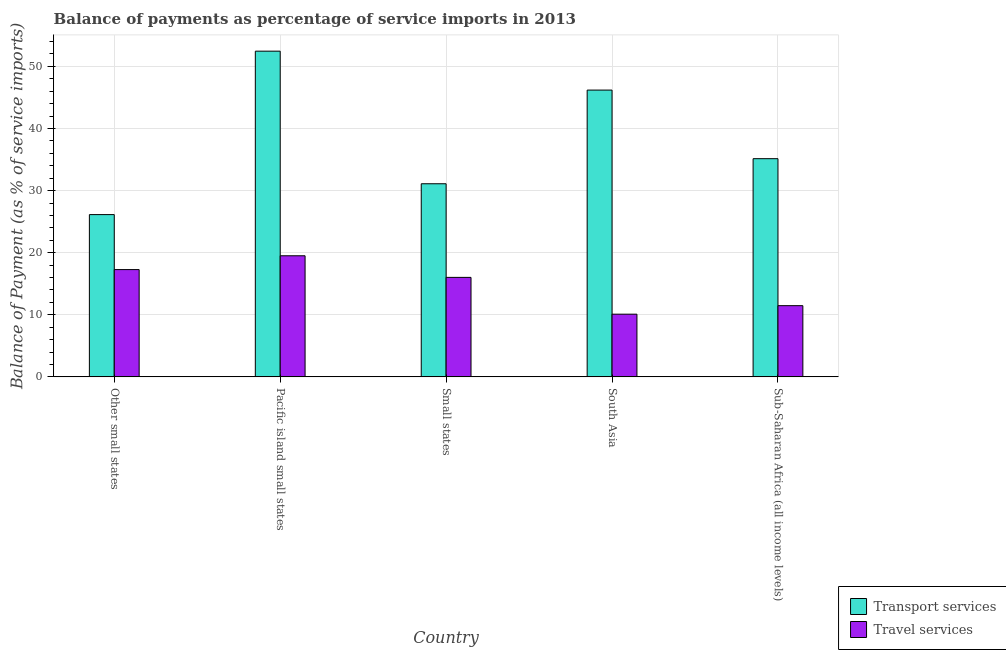How many different coloured bars are there?
Give a very brief answer. 2. How many groups of bars are there?
Offer a terse response. 5. Are the number of bars on each tick of the X-axis equal?
Provide a short and direct response. Yes. How many bars are there on the 1st tick from the left?
Provide a succinct answer. 2. What is the label of the 2nd group of bars from the left?
Keep it short and to the point. Pacific island small states. What is the balance of payments of transport services in Pacific island small states?
Provide a succinct answer. 52.45. Across all countries, what is the maximum balance of payments of travel services?
Offer a terse response. 19.5. Across all countries, what is the minimum balance of payments of travel services?
Provide a succinct answer. 10.1. In which country was the balance of payments of travel services maximum?
Offer a very short reply. Pacific island small states. In which country was the balance of payments of travel services minimum?
Offer a very short reply. South Asia. What is the total balance of payments of transport services in the graph?
Keep it short and to the point. 191.01. What is the difference between the balance of payments of travel services in Other small states and that in Small states?
Provide a short and direct response. 1.26. What is the difference between the balance of payments of travel services in Sub-Saharan Africa (all income levels) and the balance of payments of transport services in South Asia?
Provide a succinct answer. -34.72. What is the average balance of payments of transport services per country?
Provide a short and direct response. 38.2. What is the difference between the balance of payments of travel services and balance of payments of transport services in Pacific island small states?
Your response must be concise. -32.95. What is the ratio of the balance of payments of transport services in South Asia to that in Sub-Saharan Africa (all income levels)?
Keep it short and to the point. 1.31. What is the difference between the highest and the second highest balance of payments of transport services?
Offer a terse response. 6.27. What is the difference between the highest and the lowest balance of payments of transport services?
Your answer should be compact. 26.32. What does the 1st bar from the left in South Asia represents?
Your answer should be very brief. Transport services. What does the 1st bar from the right in Small states represents?
Give a very brief answer. Travel services. How many bars are there?
Your answer should be very brief. 10. How many countries are there in the graph?
Your answer should be very brief. 5. Are the values on the major ticks of Y-axis written in scientific E-notation?
Provide a succinct answer. No. Does the graph contain grids?
Your answer should be compact. Yes. Where does the legend appear in the graph?
Keep it short and to the point. Bottom right. How many legend labels are there?
Make the answer very short. 2. How are the legend labels stacked?
Keep it short and to the point. Vertical. What is the title of the graph?
Provide a succinct answer. Balance of payments as percentage of service imports in 2013. What is the label or title of the Y-axis?
Offer a very short reply. Balance of Payment (as % of service imports). What is the Balance of Payment (as % of service imports) in Transport services in Other small states?
Provide a succinct answer. 26.13. What is the Balance of Payment (as % of service imports) of Travel services in Other small states?
Make the answer very short. 17.28. What is the Balance of Payment (as % of service imports) of Transport services in Pacific island small states?
Your answer should be very brief. 52.45. What is the Balance of Payment (as % of service imports) of Travel services in Pacific island small states?
Your response must be concise. 19.5. What is the Balance of Payment (as % of service imports) of Transport services in Small states?
Provide a short and direct response. 31.1. What is the Balance of Payment (as % of service imports) in Travel services in Small states?
Your response must be concise. 16.02. What is the Balance of Payment (as % of service imports) in Transport services in South Asia?
Ensure brevity in your answer.  46.18. What is the Balance of Payment (as % of service imports) of Travel services in South Asia?
Offer a terse response. 10.1. What is the Balance of Payment (as % of service imports) of Transport services in Sub-Saharan Africa (all income levels)?
Provide a short and direct response. 35.14. What is the Balance of Payment (as % of service imports) in Travel services in Sub-Saharan Africa (all income levels)?
Make the answer very short. 11.47. Across all countries, what is the maximum Balance of Payment (as % of service imports) of Transport services?
Your response must be concise. 52.45. Across all countries, what is the maximum Balance of Payment (as % of service imports) in Travel services?
Keep it short and to the point. 19.5. Across all countries, what is the minimum Balance of Payment (as % of service imports) in Transport services?
Offer a terse response. 26.13. Across all countries, what is the minimum Balance of Payment (as % of service imports) in Travel services?
Offer a very short reply. 10.1. What is the total Balance of Payment (as % of service imports) in Transport services in the graph?
Your answer should be compact. 191.01. What is the total Balance of Payment (as % of service imports) in Travel services in the graph?
Make the answer very short. 74.36. What is the difference between the Balance of Payment (as % of service imports) in Transport services in Other small states and that in Pacific island small states?
Give a very brief answer. -26.32. What is the difference between the Balance of Payment (as % of service imports) of Travel services in Other small states and that in Pacific island small states?
Your answer should be very brief. -2.23. What is the difference between the Balance of Payment (as % of service imports) of Transport services in Other small states and that in Small states?
Your answer should be very brief. -4.97. What is the difference between the Balance of Payment (as % of service imports) of Travel services in Other small states and that in Small states?
Keep it short and to the point. 1.25. What is the difference between the Balance of Payment (as % of service imports) of Transport services in Other small states and that in South Asia?
Keep it short and to the point. -20.05. What is the difference between the Balance of Payment (as % of service imports) in Travel services in Other small states and that in South Asia?
Keep it short and to the point. 7.18. What is the difference between the Balance of Payment (as % of service imports) of Transport services in Other small states and that in Sub-Saharan Africa (all income levels)?
Provide a short and direct response. -9.01. What is the difference between the Balance of Payment (as % of service imports) of Travel services in Other small states and that in Sub-Saharan Africa (all income levels)?
Provide a succinct answer. 5.81. What is the difference between the Balance of Payment (as % of service imports) in Transport services in Pacific island small states and that in Small states?
Your answer should be very brief. 21.35. What is the difference between the Balance of Payment (as % of service imports) of Travel services in Pacific island small states and that in Small states?
Offer a very short reply. 3.48. What is the difference between the Balance of Payment (as % of service imports) of Transport services in Pacific island small states and that in South Asia?
Keep it short and to the point. 6.27. What is the difference between the Balance of Payment (as % of service imports) in Travel services in Pacific island small states and that in South Asia?
Give a very brief answer. 9.4. What is the difference between the Balance of Payment (as % of service imports) of Transport services in Pacific island small states and that in Sub-Saharan Africa (all income levels)?
Ensure brevity in your answer.  17.32. What is the difference between the Balance of Payment (as % of service imports) in Travel services in Pacific island small states and that in Sub-Saharan Africa (all income levels)?
Provide a short and direct response. 8.03. What is the difference between the Balance of Payment (as % of service imports) in Transport services in Small states and that in South Asia?
Ensure brevity in your answer.  -15.08. What is the difference between the Balance of Payment (as % of service imports) in Travel services in Small states and that in South Asia?
Offer a very short reply. 5.92. What is the difference between the Balance of Payment (as % of service imports) of Transport services in Small states and that in Sub-Saharan Africa (all income levels)?
Keep it short and to the point. -4.04. What is the difference between the Balance of Payment (as % of service imports) in Travel services in Small states and that in Sub-Saharan Africa (all income levels)?
Ensure brevity in your answer.  4.55. What is the difference between the Balance of Payment (as % of service imports) in Transport services in South Asia and that in Sub-Saharan Africa (all income levels)?
Your answer should be compact. 11.05. What is the difference between the Balance of Payment (as % of service imports) in Travel services in South Asia and that in Sub-Saharan Africa (all income levels)?
Your answer should be compact. -1.37. What is the difference between the Balance of Payment (as % of service imports) of Transport services in Other small states and the Balance of Payment (as % of service imports) of Travel services in Pacific island small states?
Your answer should be compact. 6.63. What is the difference between the Balance of Payment (as % of service imports) of Transport services in Other small states and the Balance of Payment (as % of service imports) of Travel services in Small states?
Provide a short and direct response. 10.11. What is the difference between the Balance of Payment (as % of service imports) in Transport services in Other small states and the Balance of Payment (as % of service imports) in Travel services in South Asia?
Ensure brevity in your answer.  16.04. What is the difference between the Balance of Payment (as % of service imports) of Transport services in Other small states and the Balance of Payment (as % of service imports) of Travel services in Sub-Saharan Africa (all income levels)?
Provide a succinct answer. 14.66. What is the difference between the Balance of Payment (as % of service imports) of Transport services in Pacific island small states and the Balance of Payment (as % of service imports) of Travel services in Small states?
Offer a terse response. 36.43. What is the difference between the Balance of Payment (as % of service imports) of Transport services in Pacific island small states and the Balance of Payment (as % of service imports) of Travel services in South Asia?
Offer a very short reply. 42.36. What is the difference between the Balance of Payment (as % of service imports) of Transport services in Pacific island small states and the Balance of Payment (as % of service imports) of Travel services in Sub-Saharan Africa (all income levels)?
Ensure brevity in your answer.  40.99. What is the difference between the Balance of Payment (as % of service imports) of Transport services in Small states and the Balance of Payment (as % of service imports) of Travel services in South Asia?
Provide a short and direct response. 21. What is the difference between the Balance of Payment (as % of service imports) in Transport services in Small states and the Balance of Payment (as % of service imports) in Travel services in Sub-Saharan Africa (all income levels)?
Provide a succinct answer. 19.63. What is the difference between the Balance of Payment (as % of service imports) of Transport services in South Asia and the Balance of Payment (as % of service imports) of Travel services in Sub-Saharan Africa (all income levels)?
Give a very brief answer. 34.72. What is the average Balance of Payment (as % of service imports) in Transport services per country?
Keep it short and to the point. 38.2. What is the average Balance of Payment (as % of service imports) of Travel services per country?
Offer a very short reply. 14.87. What is the difference between the Balance of Payment (as % of service imports) of Transport services and Balance of Payment (as % of service imports) of Travel services in Other small states?
Ensure brevity in your answer.  8.86. What is the difference between the Balance of Payment (as % of service imports) in Transport services and Balance of Payment (as % of service imports) in Travel services in Pacific island small states?
Provide a short and direct response. 32.95. What is the difference between the Balance of Payment (as % of service imports) in Transport services and Balance of Payment (as % of service imports) in Travel services in Small states?
Provide a succinct answer. 15.08. What is the difference between the Balance of Payment (as % of service imports) of Transport services and Balance of Payment (as % of service imports) of Travel services in South Asia?
Your response must be concise. 36.09. What is the difference between the Balance of Payment (as % of service imports) of Transport services and Balance of Payment (as % of service imports) of Travel services in Sub-Saharan Africa (all income levels)?
Offer a terse response. 23.67. What is the ratio of the Balance of Payment (as % of service imports) in Transport services in Other small states to that in Pacific island small states?
Give a very brief answer. 0.5. What is the ratio of the Balance of Payment (as % of service imports) of Travel services in Other small states to that in Pacific island small states?
Your answer should be very brief. 0.89. What is the ratio of the Balance of Payment (as % of service imports) of Transport services in Other small states to that in Small states?
Your response must be concise. 0.84. What is the ratio of the Balance of Payment (as % of service imports) of Travel services in Other small states to that in Small states?
Provide a succinct answer. 1.08. What is the ratio of the Balance of Payment (as % of service imports) of Transport services in Other small states to that in South Asia?
Give a very brief answer. 0.57. What is the ratio of the Balance of Payment (as % of service imports) of Travel services in Other small states to that in South Asia?
Your answer should be compact. 1.71. What is the ratio of the Balance of Payment (as % of service imports) of Transport services in Other small states to that in Sub-Saharan Africa (all income levels)?
Offer a terse response. 0.74. What is the ratio of the Balance of Payment (as % of service imports) of Travel services in Other small states to that in Sub-Saharan Africa (all income levels)?
Provide a succinct answer. 1.51. What is the ratio of the Balance of Payment (as % of service imports) of Transport services in Pacific island small states to that in Small states?
Ensure brevity in your answer.  1.69. What is the ratio of the Balance of Payment (as % of service imports) in Travel services in Pacific island small states to that in Small states?
Give a very brief answer. 1.22. What is the ratio of the Balance of Payment (as % of service imports) of Transport services in Pacific island small states to that in South Asia?
Offer a very short reply. 1.14. What is the ratio of the Balance of Payment (as % of service imports) in Travel services in Pacific island small states to that in South Asia?
Ensure brevity in your answer.  1.93. What is the ratio of the Balance of Payment (as % of service imports) in Transport services in Pacific island small states to that in Sub-Saharan Africa (all income levels)?
Ensure brevity in your answer.  1.49. What is the ratio of the Balance of Payment (as % of service imports) in Travel services in Pacific island small states to that in Sub-Saharan Africa (all income levels)?
Provide a succinct answer. 1.7. What is the ratio of the Balance of Payment (as % of service imports) of Transport services in Small states to that in South Asia?
Provide a succinct answer. 0.67. What is the ratio of the Balance of Payment (as % of service imports) of Travel services in Small states to that in South Asia?
Provide a succinct answer. 1.59. What is the ratio of the Balance of Payment (as % of service imports) of Transport services in Small states to that in Sub-Saharan Africa (all income levels)?
Your response must be concise. 0.89. What is the ratio of the Balance of Payment (as % of service imports) in Travel services in Small states to that in Sub-Saharan Africa (all income levels)?
Your answer should be very brief. 1.4. What is the ratio of the Balance of Payment (as % of service imports) of Transport services in South Asia to that in Sub-Saharan Africa (all income levels)?
Your response must be concise. 1.31. What is the ratio of the Balance of Payment (as % of service imports) of Travel services in South Asia to that in Sub-Saharan Africa (all income levels)?
Your answer should be compact. 0.88. What is the difference between the highest and the second highest Balance of Payment (as % of service imports) in Transport services?
Provide a short and direct response. 6.27. What is the difference between the highest and the second highest Balance of Payment (as % of service imports) of Travel services?
Your answer should be compact. 2.23. What is the difference between the highest and the lowest Balance of Payment (as % of service imports) of Transport services?
Offer a terse response. 26.32. What is the difference between the highest and the lowest Balance of Payment (as % of service imports) of Travel services?
Offer a very short reply. 9.4. 